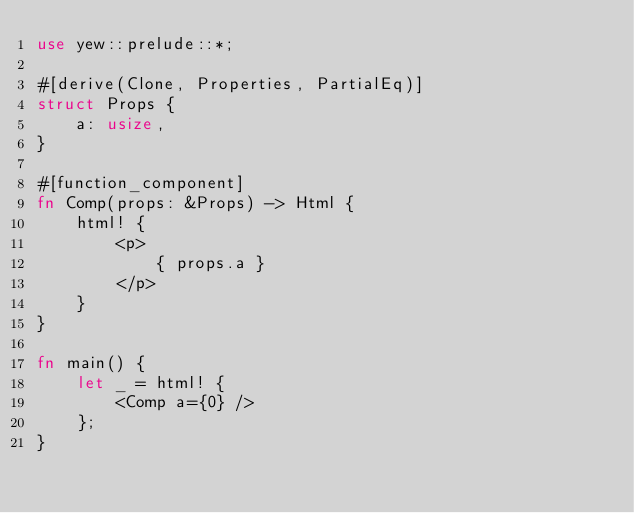<code> <loc_0><loc_0><loc_500><loc_500><_Rust_>use yew::prelude::*;

#[derive(Clone, Properties, PartialEq)]
struct Props {
    a: usize,
}

#[function_component]
fn Comp(props: &Props) -> Html {
    html! {
        <p>
            { props.a }
        </p>
    }
}

fn main() {
    let _ = html! {
        <Comp a={0} />
    };
}
</code> 